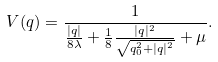Convert formula to latex. <formula><loc_0><loc_0><loc_500><loc_500>V ( q ) = \frac { 1 } { \frac { | q | } { 8 \lambda } + \frac { 1 } { 8 } \frac { | q | ^ { 2 } } { \sqrt { q _ { 0 } ^ { 2 } + | q | ^ { 2 } } } + \mu } .</formula> 